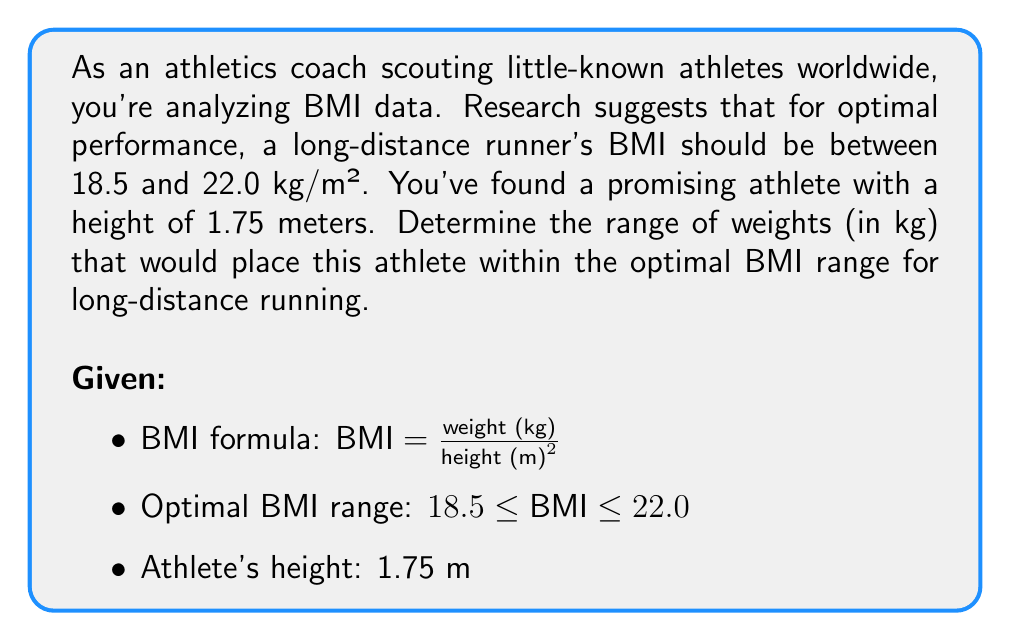Provide a solution to this math problem. To solve this problem, we'll use the BMI formula and the given optimal BMI range to create an inequality. Then we'll solve for the weight range.

1) Start with the BMI formula and substitute the known values:

   $18.5 \leq \frac{weight}{1.75^2} \leq 22.0$

2) Multiply all parts of the inequality by $1.75^2$:

   $18.5 \cdot 1.75^2 \leq weight \leq 22.0 \cdot 1.75^2$

3) Calculate the values:

   $18.5 \cdot 3.0625 \leq weight \leq 22.0 \cdot 3.0625$
   
   $56.65625 \leq weight \leq 67.375$

4) Round to a reasonable precision (0.1 kg):

   $56.7 \leq weight \leq 67.4$

Therefore, the optimal weight range for this athlete is between 56.7 kg and 67.4 kg.
Answer: The optimal weight range for the athlete is $56.7 \leq weight \leq 67.4$ kg. 